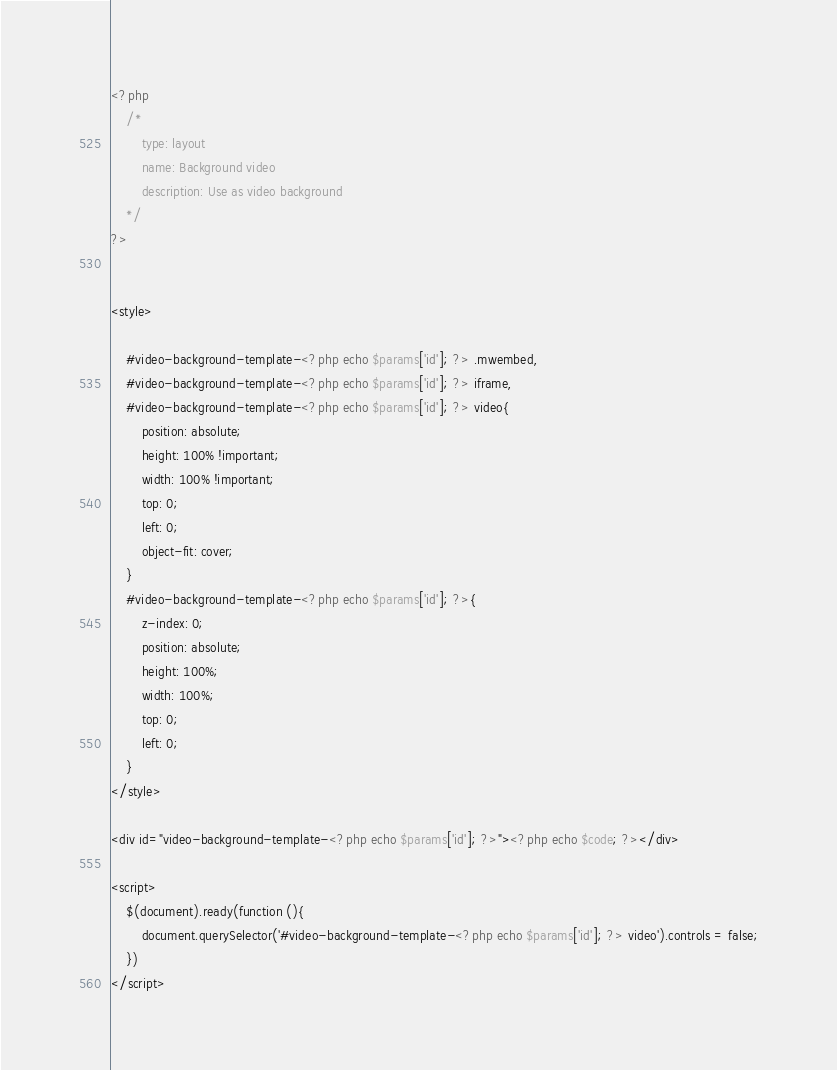<code> <loc_0><loc_0><loc_500><loc_500><_PHP_><?php
    /*
        type: layout
        name: Background video
        description: Use as video background
    */
?>


<style>

    #video-background-template-<?php echo $params['id']; ?> .mwembed,
    #video-background-template-<?php echo $params['id']; ?> iframe,
    #video-background-template-<?php echo $params['id']; ?> video{
        position: absolute;
        height: 100% !important;
        width: 100% !important;
        top: 0;
        left: 0;
        object-fit: cover;
    }
    #video-background-template-<?php echo $params['id']; ?>{
        z-index: 0;
        position: absolute;
        height: 100%;
        width: 100%;
        top: 0;
        left: 0;
    }
</style>

<div id="video-background-template-<?php echo $params['id']; ?>"><?php echo $code; ?></div>

<script>
    $(document).ready(function (){
        document.querySelector('#video-background-template-<?php echo $params['id']; ?> video').controls = false;
    })
</script>

</code> 